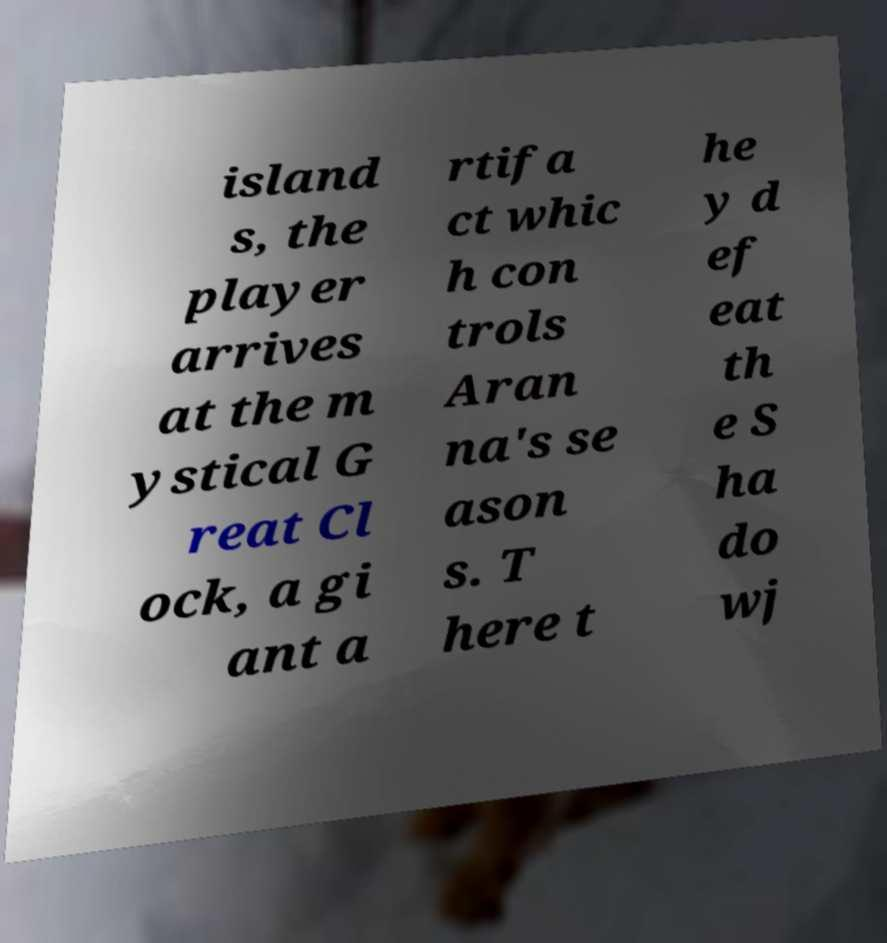Please identify and transcribe the text found in this image. island s, the player arrives at the m ystical G reat Cl ock, a gi ant a rtifa ct whic h con trols Aran na's se ason s. T here t he y d ef eat th e S ha do wj 